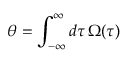Convert formula to latex. <formula><loc_0><loc_0><loc_500><loc_500>\theta = \int _ { - \infty } ^ { \infty } d \tau \, \Omega ( \tau )</formula> 